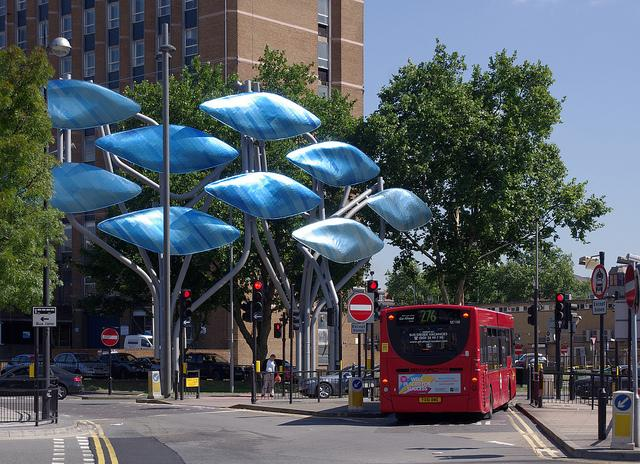What type of art is this?

Choices:
A) sand
B) painting
C) drawing
D) sculpture sculpture 